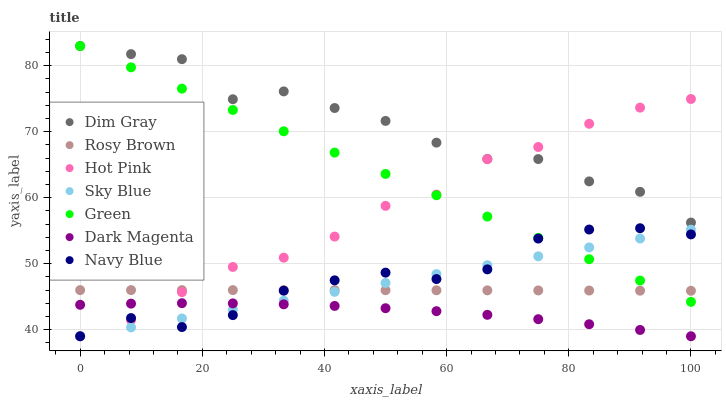Does Dark Magenta have the minimum area under the curve?
Answer yes or no. Yes. Does Dim Gray have the maximum area under the curve?
Answer yes or no. Yes. Does Navy Blue have the minimum area under the curve?
Answer yes or no. No. Does Navy Blue have the maximum area under the curve?
Answer yes or no. No. Is Sky Blue the smoothest?
Answer yes or no. Yes. Is Dim Gray the roughest?
Answer yes or no. Yes. Is Dark Magenta the smoothest?
Answer yes or no. No. Is Dark Magenta the roughest?
Answer yes or no. No. Does Dark Magenta have the lowest value?
Answer yes or no. Yes. Does Rosy Brown have the lowest value?
Answer yes or no. No. Does Green have the highest value?
Answer yes or no. Yes. Does Navy Blue have the highest value?
Answer yes or no. No. Is Dark Magenta less than Green?
Answer yes or no. Yes. Is Dim Gray greater than Dark Magenta?
Answer yes or no. Yes. Does Dim Gray intersect Hot Pink?
Answer yes or no. Yes. Is Dim Gray less than Hot Pink?
Answer yes or no. No. Is Dim Gray greater than Hot Pink?
Answer yes or no. No. Does Dark Magenta intersect Green?
Answer yes or no. No. 